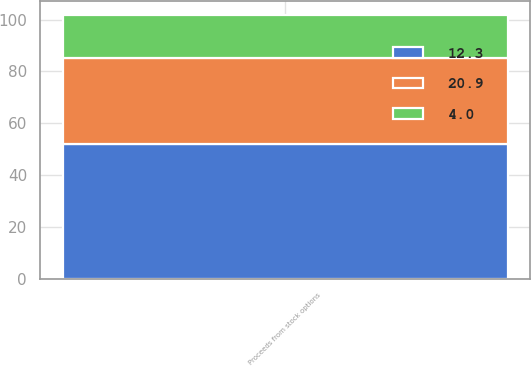Convert chart. <chart><loc_0><loc_0><loc_500><loc_500><stacked_bar_chart><ecel><fcel>Proceeds from stock options<nl><fcel>4<fcel>16.9<nl><fcel>20.9<fcel>33<nl><fcel>12.3<fcel>52<nl></chart> 